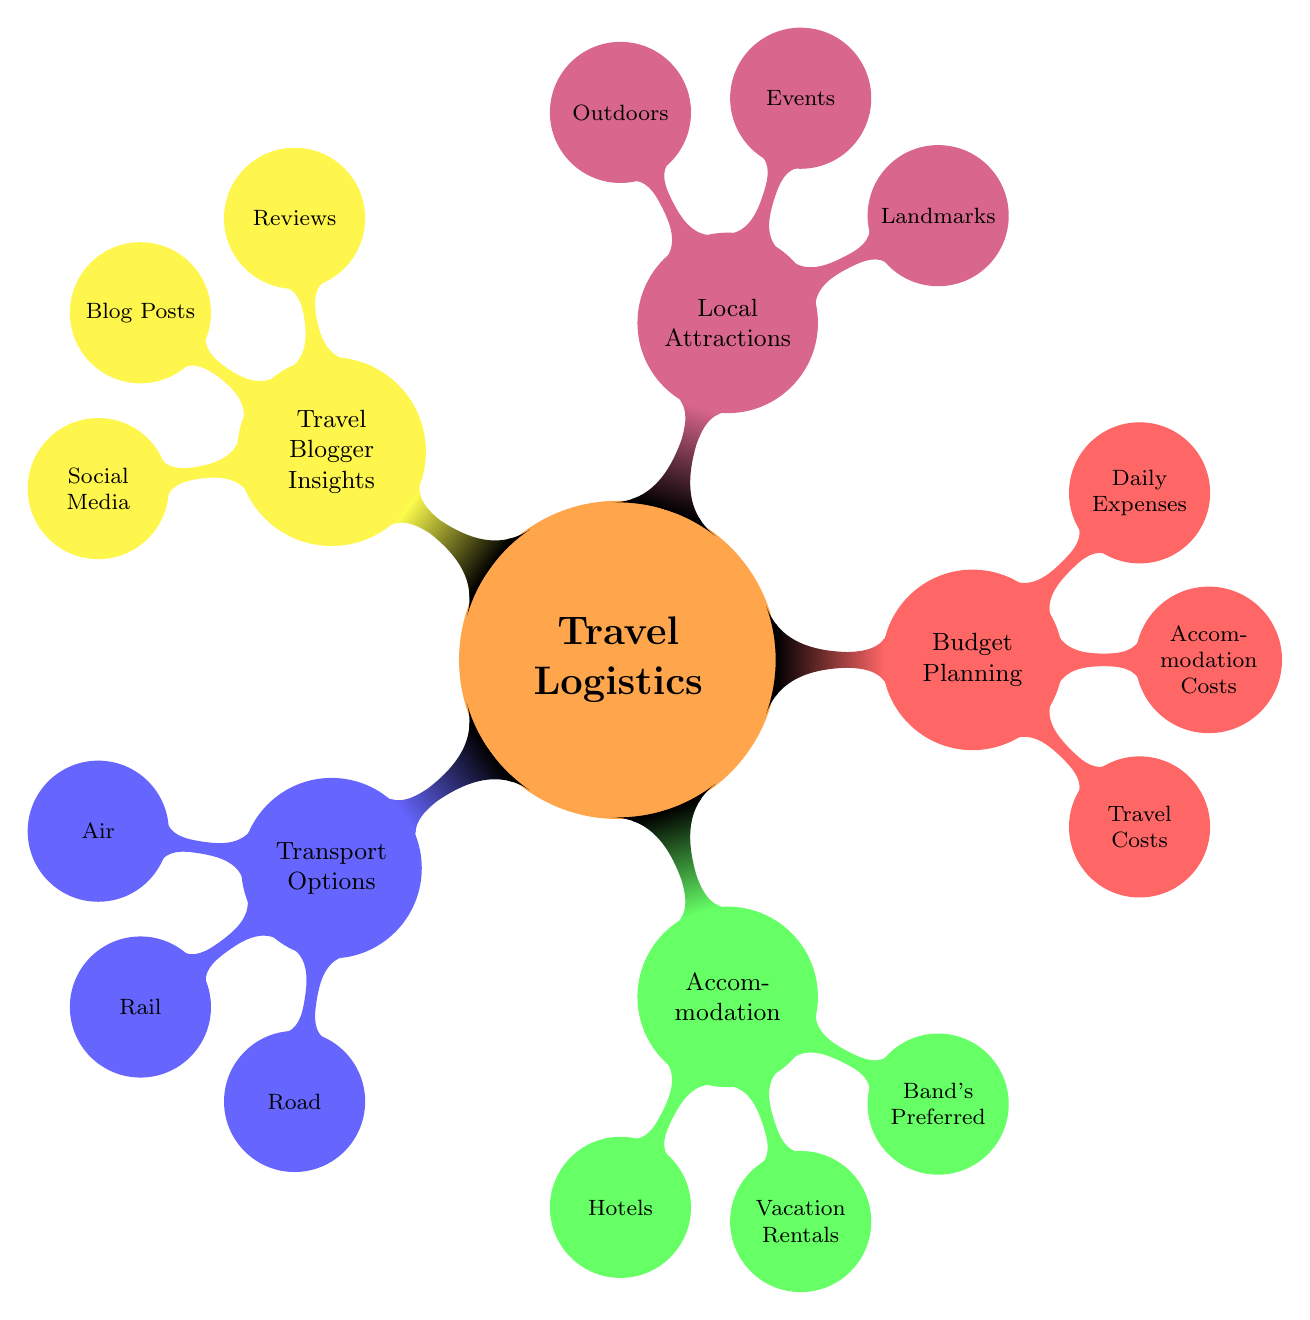What are the transport options available? The diagram lists three main types of transport options: Air, Rail, and Road.
Answer: Air, Rail, Road How many accommodation types are there? The accommodation node has three sub-nodes: Hotels, Vacation Rentals, and Band's Preferred Options.
Answer: 3 What is included in the budget planning category? The budget planning node includes three main categories: Travel Costs, Accommodation Costs, and Daily Expenses.
Answer: Travel Costs, Accommodation Costs, Daily Expenses Which local attraction falls under landmarks? The local attractions node specifies three sub-categories, one of which is Landmarks, including examples like Grand Ole Opry.
Answer: Grand Ole Opry Which travel blogger insights are provided? The insights cover three areas: Reviews, Blog Posts, and Social Media, indicating various sources of information.
Answer: Reviews, Blog Posts, Social Media How many transport options do you need to consider? Under each mode of transport in the Transport Options, there are several specific examples, indicating a variety of choices to consider in each category.
Answer: 6 What type of accommodation does the band prefer? Within the Accommodation node, Band's Preferred Options specifies two choices: Motel 6 and Best Western.
Answer: Motel 6, Best Western What can be categorized as outdoor attractions? The Outdoors category under Local Attractions provides options like National Parks and Scenic Routes.
Answer: National Parks, Scenic Routes Which transportation mode is the only rail option listed? The diagram specifically mentions Amtrak under the Rail sub-node, indicating it as the only detailed rail transport option.
Answer: Amtrak 